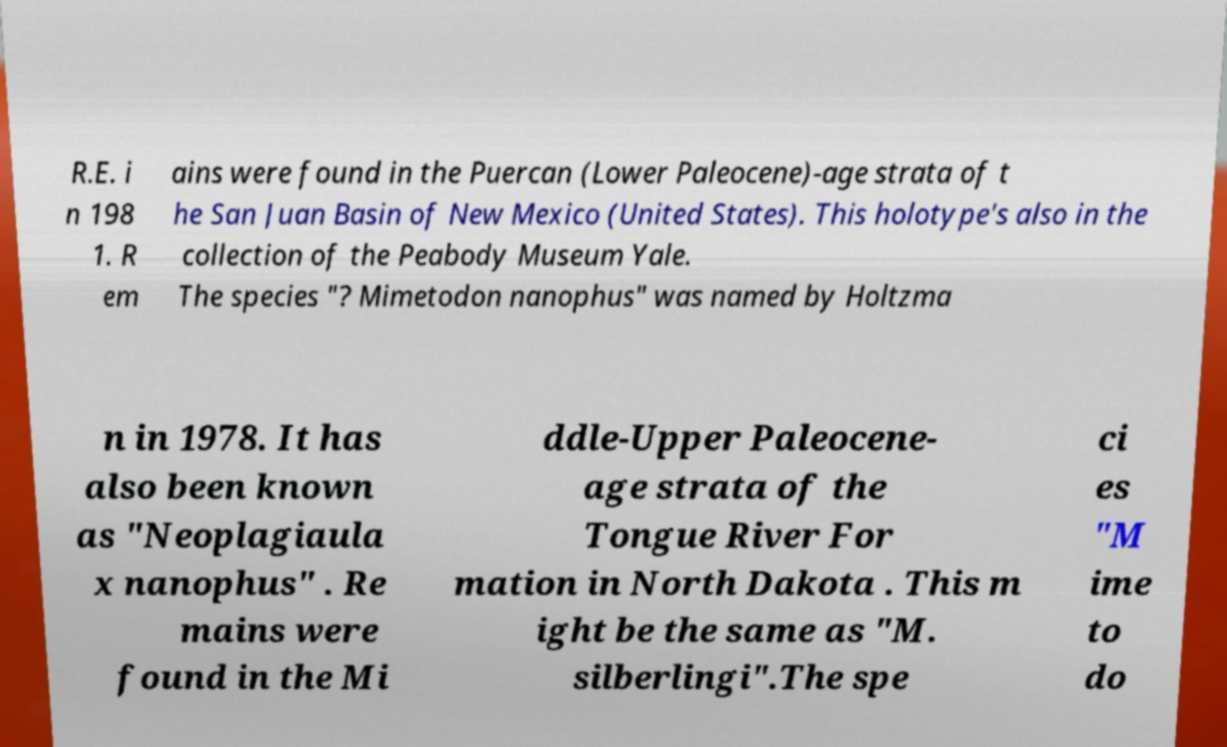There's text embedded in this image that I need extracted. Can you transcribe it verbatim? R.E. i n 198 1. R em ains were found in the Puercan (Lower Paleocene)-age strata of t he San Juan Basin of New Mexico (United States). This holotype's also in the collection of the Peabody Museum Yale. The species "? Mimetodon nanophus" was named by Holtzma n in 1978. It has also been known as "Neoplagiaula x nanophus" . Re mains were found in the Mi ddle-Upper Paleocene- age strata of the Tongue River For mation in North Dakota . This m ight be the same as "M. silberlingi".The spe ci es "M ime to do 